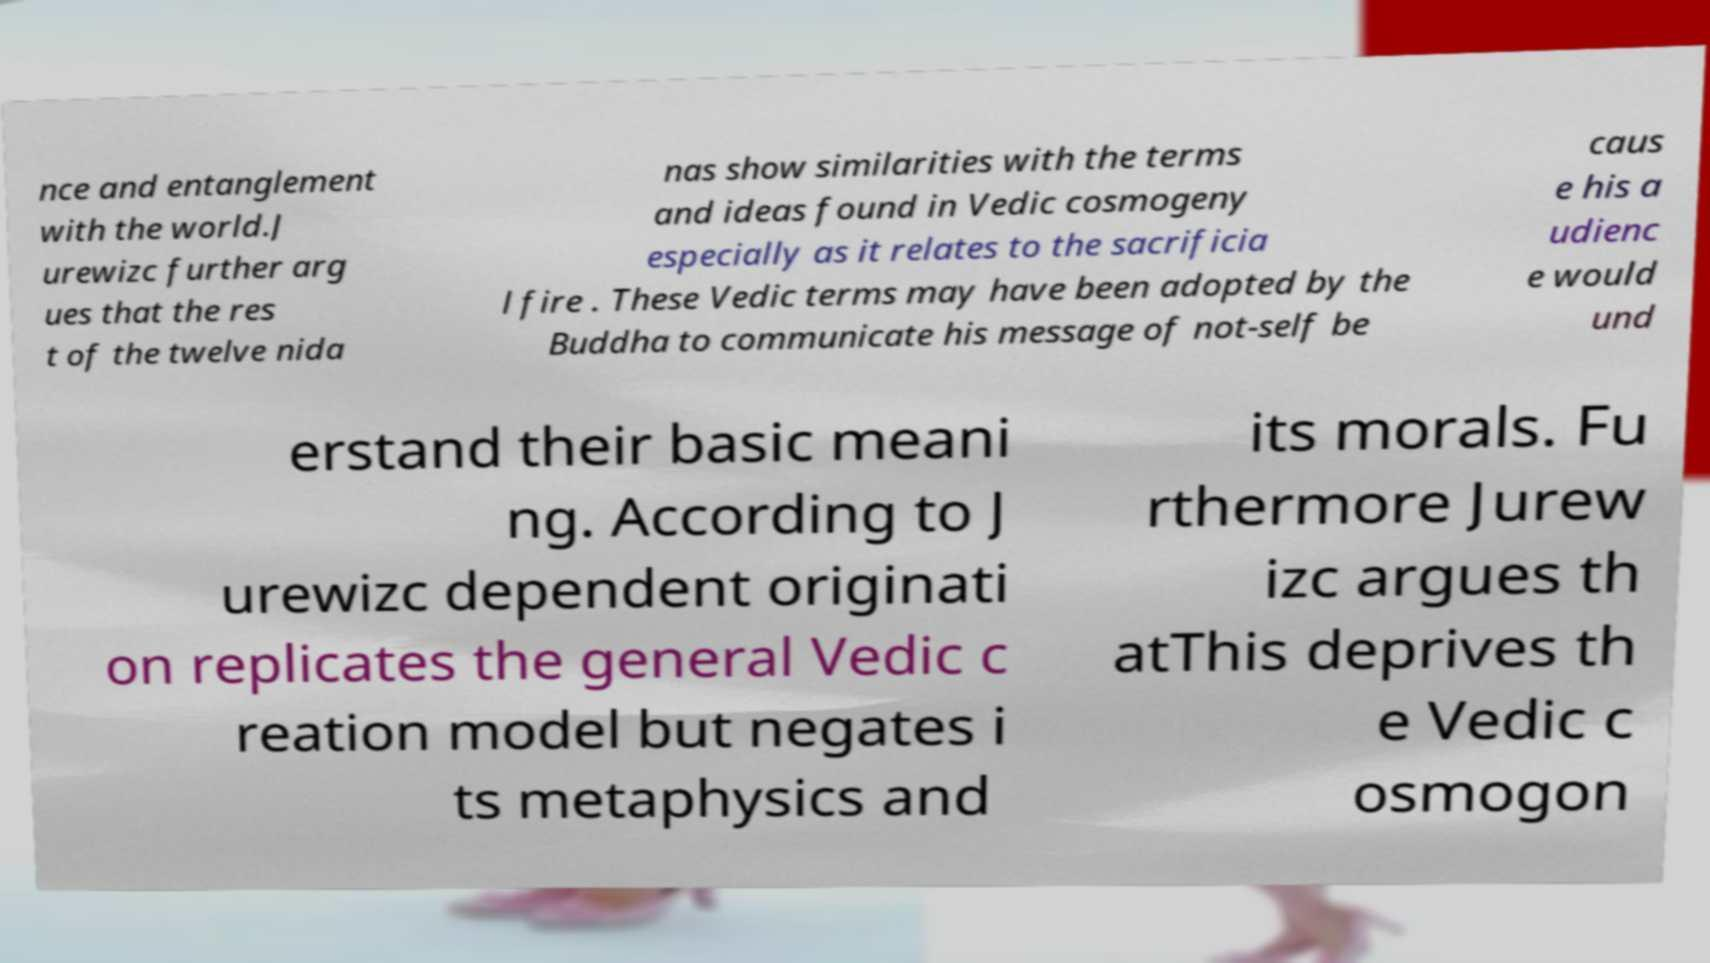Could you extract and type out the text from this image? nce and entanglement with the world.J urewizc further arg ues that the res t of the twelve nida nas show similarities with the terms and ideas found in Vedic cosmogeny especially as it relates to the sacrificia l fire . These Vedic terms may have been adopted by the Buddha to communicate his message of not-self be caus e his a udienc e would und erstand their basic meani ng. According to J urewizc dependent originati on replicates the general Vedic c reation model but negates i ts metaphysics and its morals. Fu rthermore Jurew izc argues th atThis deprives th e Vedic c osmogon 